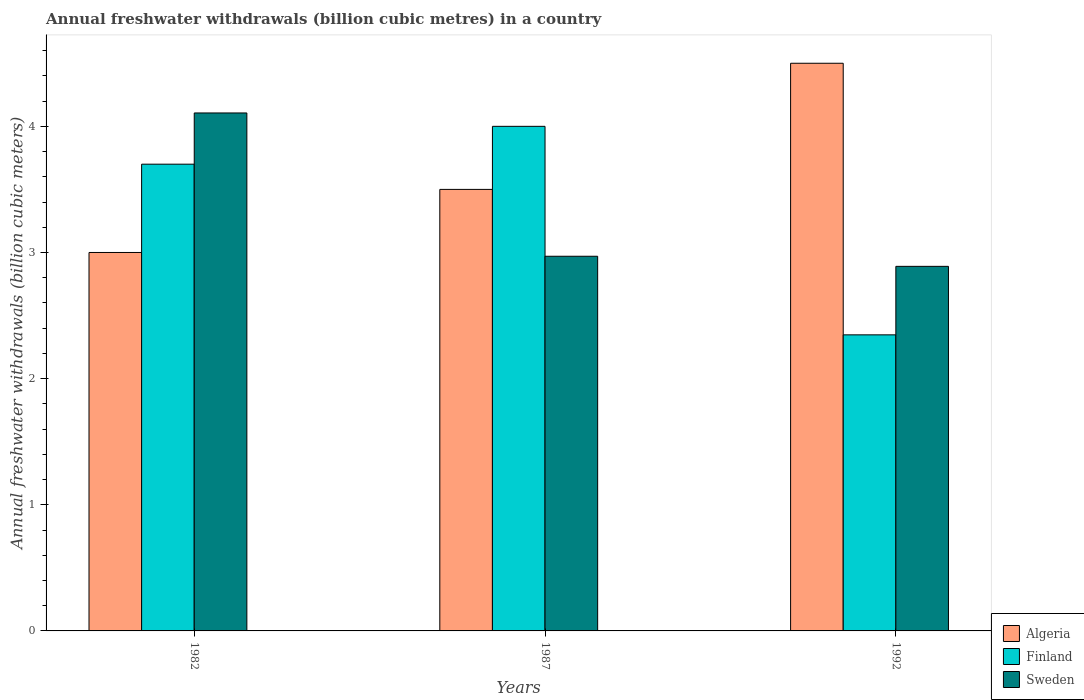Are the number of bars per tick equal to the number of legend labels?
Give a very brief answer. Yes. Are the number of bars on each tick of the X-axis equal?
Your answer should be compact. Yes. How many bars are there on the 1st tick from the left?
Give a very brief answer. 3. How many bars are there on the 1st tick from the right?
Provide a short and direct response. 3. What is the label of the 3rd group of bars from the left?
Give a very brief answer. 1992. In how many cases, is the number of bars for a given year not equal to the number of legend labels?
Your answer should be compact. 0. What is the annual freshwater withdrawals in Sweden in 1982?
Make the answer very short. 4.11. Across all years, what is the minimum annual freshwater withdrawals in Finland?
Provide a succinct answer. 2.35. In which year was the annual freshwater withdrawals in Sweden maximum?
Provide a short and direct response. 1982. What is the total annual freshwater withdrawals in Algeria in the graph?
Your response must be concise. 11. What is the difference between the annual freshwater withdrawals in Sweden in 1982 and that in 1992?
Give a very brief answer. 1.22. What is the difference between the annual freshwater withdrawals in Sweden in 1992 and the annual freshwater withdrawals in Finland in 1987?
Your answer should be very brief. -1.11. What is the average annual freshwater withdrawals in Algeria per year?
Offer a terse response. 3.67. In the year 1992, what is the difference between the annual freshwater withdrawals in Finland and annual freshwater withdrawals in Algeria?
Provide a succinct answer. -2.15. In how many years, is the annual freshwater withdrawals in Sweden greater than 4.4 billion cubic meters?
Your response must be concise. 0. What is the ratio of the annual freshwater withdrawals in Algeria in 1987 to that in 1992?
Provide a succinct answer. 0.78. Is the annual freshwater withdrawals in Finland in 1987 less than that in 1992?
Offer a very short reply. No. What is the difference between the highest and the second highest annual freshwater withdrawals in Sweden?
Offer a terse response. 1.14. What is the difference between the highest and the lowest annual freshwater withdrawals in Finland?
Offer a very short reply. 1.65. In how many years, is the annual freshwater withdrawals in Sweden greater than the average annual freshwater withdrawals in Sweden taken over all years?
Provide a succinct answer. 1. Is the sum of the annual freshwater withdrawals in Sweden in 1987 and 1992 greater than the maximum annual freshwater withdrawals in Finland across all years?
Provide a short and direct response. Yes. What does the 2nd bar from the right in 1992 represents?
Make the answer very short. Finland. Does the graph contain grids?
Your answer should be very brief. No. How many legend labels are there?
Provide a succinct answer. 3. What is the title of the graph?
Keep it short and to the point. Annual freshwater withdrawals (billion cubic metres) in a country. What is the label or title of the Y-axis?
Your answer should be very brief. Annual freshwater withdrawals (billion cubic meters). What is the Annual freshwater withdrawals (billion cubic meters) in Algeria in 1982?
Ensure brevity in your answer.  3. What is the Annual freshwater withdrawals (billion cubic meters) of Finland in 1982?
Provide a short and direct response. 3.7. What is the Annual freshwater withdrawals (billion cubic meters) in Sweden in 1982?
Offer a terse response. 4.11. What is the Annual freshwater withdrawals (billion cubic meters) of Finland in 1987?
Keep it short and to the point. 4. What is the Annual freshwater withdrawals (billion cubic meters) of Sweden in 1987?
Provide a succinct answer. 2.97. What is the Annual freshwater withdrawals (billion cubic meters) in Finland in 1992?
Provide a succinct answer. 2.35. What is the Annual freshwater withdrawals (billion cubic meters) in Sweden in 1992?
Ensure brevity in your answer.  2.89. Across all years, what is the maximum Annual freshwater withdrawals (billion cubic meters) in Algeria?
Give a very brief answer. 4.5. Across all years, what is the maximum Annual freshwater withdrawals (billion cubic meters) of Finland?
Ensure brevity in your answer.  4. Across all years, what is the maximum Annual freshwater withdrawals (billion cubic meters) of Sweden?
Make the answer very short. 4.11. Across all years, what is the minimum Annual freshwater withdrawals (billion cubic meters) of Finland?
Provide a succinct answer. 2.35. Across all years, what is the minimum Annual freshwater withdrawals (billion cubic meters) in Sweden?
Your response must be concise. 2.89. What is the total Annual freshwater withdrawals (billion cubic meters) in Finland in the graph?
Offer a very short reply. 10.05. What is the total Annual freshwater withdrawals (billion cubic meters) of Sweden in the graph?
Make the answer very short. 9.97. What is the difference between the Annual freshwater withdrawals (billion cubic meters) of Finland in 1982 and that in 1987?
Give a very brief answer. -0.3. What is the difference between the Annual freshwater withdrawals (billion cubic meters) in Sweden in 1982 and that in 1987?
Keep it short and to the point. 1.14. What is the difference between the Annual freshwater withdrawals (billion cubic meters) of Finland in 1982 and that in 1992?
Your answer should be compact. 1.35. What is the difference between the Annual freshwater withdrawals (billion cubic meters) of Sweden in 1982 and that in 1992?
Keep it short and to the point. 1.22. What is the difference between the Annual freshwater withdrawals (billion cubic meters) in Finland in 1987 and that in 1992?
Keep it short and to the point. 1.65. What is the difference between the Annual freshwater withdrawals (billion cubic meters) in Algeria in 1982 and the Annual freshwater withdrawals (billion cubic meters) in Finland in 1987?
Your answer should be very brief. -1. What is the difference between the Annual freshwater withdrawals (billion cubic meters) in Algeria in 1982 and the Annual freshwater withdrawals (billion cubic meters) in Sweden in 1987?
Keep it short and to the point. 0.03. What is the difference between the Annual freshwater withdrawals (billion cubic meters) of Finland in 1982 and the Annual freshwater withdrawals (billion cubic meters) of Sweden in 1987?
Provide a succinct answer. 0.73. What is the difference between the Annual freshwater withdrawals (billion cubic meters) in Algeria in 1982 and the Annual freshwater withdrawals (billion cubic meters) in Finland in 1992?
Keep it short and to the point. 0.65. What is the difference between the Annual freshwater withdrawals (billion cubic meters) in Algeria in 1982 and the Annual freshwater withdrawals (billion cubic meters) in Sweden in 1992?
Your answer should be compact. 0.11. What is the difference between the Annual freshwater withdrawals (billion cubic meters) in Finland in 1982 and the Annual freshwater withdrawals (billion cubic meters) in Sweden in 1992?
Offer a terse response. 0.81. What is the difference between the Annual freshwater withdrawals (billion cubic meters) in Algeria in 1987 and the Annual freshwater withdrawals (billion cubic meters) in Finland in 1992?
Provide a short and direct response. 1.15. What is the difference between the Annual freshwater withdrawals (billion cubic meters) of Algeria in 1987 and the Annual freshwater withdrawals (billion cubic meters) of Sweden in 1992?
Give a very brief answer. 0.61. What is the difference between the Annual freshwater withdrawals (billion cubic meters) of Finland in 1987 and the Annual freshwater withdrawals (billion cubic meters) of Sweden in 1992?
Offer a very short reply. 1.11. What is the average Annual freshwater withdrawals (billion cubic meters) in Algeria per year?
Your answer should be compact. 3.67. What is the average Annual freshwater withdrawals (billion cubic meters) in Finland per year?
Ensure brevity in your answer.  3.35. What is the average Annual freshwater withdrawals (billion cubic meters) in Sweden per year?
Your answer should be compact. 3.32. In the year 1982, what is the difference between the Annual freshwater withdrawals (billion cubic meters) in Algeria and Annual freshwater withdrawals (billion cubic meters) in Sweden?
Provide a short and direct response. -1.11. In the year 1982, what is the difference between the Annual freshwater withdrawals (billion cubic meters) in Finland and Annual freshwater withdrawals (billion cubic meters) in Sweden?
Provide a short and direct response. -0.41. In the year 1987, what is the difference between the Annual freshwater withdrawals (billion cubic meters) in Algeria and Annual freshwater withdrawals (billion cubic meters) in Sweden?
Provide a short and direct response. 0.53. In the year 1987, what is the difference between the Annual freshwater withdrawals (billion cubic meters) of Finland and Annual freshwater withdrawals (billion cubic meters) of Sweden?
Provide a succinct answer. 1.03. In the year 1992, what is the difference between the Annual freshwater withdrawals (billion cubic meters) in Algeria and Annual freshwater withdrawals (billion cubic meters) in Finland?
Provide a short and direct response. 2.15. In the year 1992, what is the difference between the Annual freshwater withdrawals (billion cubic meters) of Algeria and Annual freshwater withdrawals (billion cubic meters) of Sweden?
Offer a terse response. 1.61. In the year 1992, what is the difference between the Annual freshwater withdrawals (billion cubic meters) in Finland and Annual freshwater withdrawals (billion cubic meters) in Sweden?
Make the answer very short. -0.54. What is the ratio of the Annual freshwater withdrawals (billion cubic meters) of Finland in 1982 to that in 1987?
Provide a succinct answer. 0.93. What is the ratio of the Annual freshwater withdrawals (billion cubic meters) in Sweden in 1982 to that in 1987?
Make the answer very short. 1.38. What is the ratio of the Annual freshwater withdrawals (billion cubic meters) of Algeria in 1982 to that in 1992?
Provide a short and direct response. 0.67. What is the ratio of the Annual freshwater withdrawals (billion cubic meters) in Finland in 1982 to that in 1992?
Keep it short and to the point. 1.58. What is the ratio of the Annual freshwater withdrawals (billion cubic meters) in Sweden in 1982 to that in 1992?
Offer a terse response. 1.42. What is the ratio of the Annual freshwater withdrawals (billion cubic meters) in Finland in 1987 to that in 1992?
Provide a succinct answer. 1.7. What is the ratio of the Annual freshwater withdrawals (billion cubic meters) in Sweden in 1987 to that in 1992?
Offer a very short reply. 1.03. What is the difference between the highest and the second highest Annual freshwater withdrawals (billion cubic meters) in Algeria?
Offer a terse response. 1. What is the difference between the highest and the second highest Annual freshwater withdrawals (billion cubic meters) of Sweden?
Offer a terse response. 1.14. What is the difference between the highest and the lowest Annual freshwater withdrawals (billion cubic meters) of Algeria?
Make the answer very short. 1.5. What is the difference between the highest and the lowest Annual freshwater withdrawals (billion cubic meters) in Finland?
Your response must be concise. 1.65. What is the difference between the highest and the lowest Annual freshwater withdrawals (billion cubic meters) in Sweden?
Your answer should be compact. 1.22. 